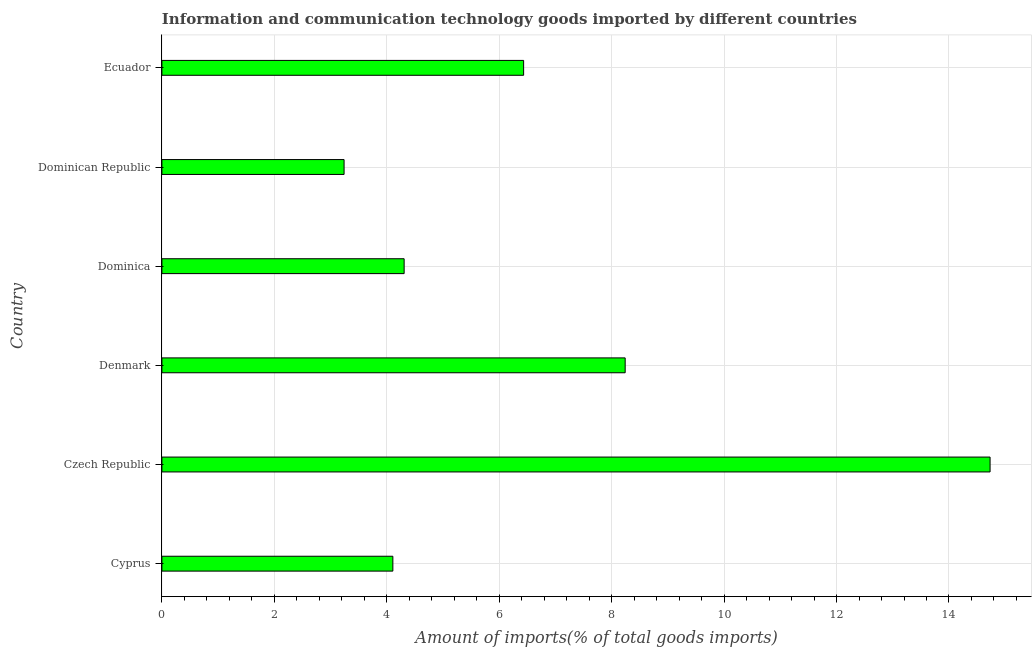Does the graph contain any zero values?
Offer a terse response. No. Does the graph contain grids?
Your answer should be compact. Yes. What is the title of the graph?
Offer a very short reply. Information and communication technology goods imported by different countries. What is the label or title of the X-axis?
Keep it short and to the point. Amount of imports(% of total goods imports). What is the label or title of the Y-axis?
Ensure brevity in your answer.  Country. What is the amount of ict goods imports in Cyprus?
Offer a terse response. 4.11. Across all countries, what is the maximum amount of ict goods imports?
Your answer should be very brief. 14.73. Across all countries, what is the minimum amount of ict goods imports?
Provide a short and direct response. 3.24. In which country was the amount of ict goods imports maximum?
Provide a short and direct response. Czech Republic. In which country was the amount of ict goods imports minimum?
Your answer should be very brief. Dominican Republic. What is the sum of the amount of ict goods imports?
Your response must be concise. 41.06. What is the difference between the amount of ict goods imports in Denmark and Dominica?
Make the answer very short. 3.93. What is the average amount of ict goods imports per country?
Ensure brevity in your answer.  6.84. What is the median amount of ict goods imports?
Your answer should be compact. 5.37. What is the ratio of the amount of ict goods imports in Denmark to that in Ecuador?
Your answer should be very brief. 1.28. Is the amount of ict goods imports in Dominica less than that in Dominican Republic?
Give a very brief answer. No. Is the difference between the amount of ict goods imports in Cyprus and Czech Republic greater than the difference between any two countries?
Offer a very short reply. No. What is the difference between the highest and the second highest amount of ict goods imports?
Offer a terse response. 6.49. Is the sum of the amount of ict goods imports in Czech Republic and Dominica greater than the maximum amount of ict goods imports across all countries?
Your response must be concise. Yes. What is the difference between the highest and the lowest amount of ict goods imports?
Your answer should be very brief. 11.49. How many bars are there?
Your response must be concise. 6. How many countries are there in the graph?
Provide a short and direct response. 6. What is the difference between two consecutive major ticks on the X-axis?
Give a very brief answer. 2. Are the values on the major ticks of X-axis written in scientific E-notation?
Keep it short and to the point. No. What is the Amount of imports(% of total goods imports) of Cyprus?
Provide a short and direct response. 4.11. What is the Amount of imports(% of total goods imports) of Czech Republic?
Your answer should be compact. 14.73. What is the Amount of imports(% of total goods imports) of Denmark?
Offer a very short reply. 8.24. What is the Amount of imports(% of total goods imports) of Dominica?
Your answer should be compact. 4.31. What is the Amount of imports(% of total goods imports) in Dominican Republic?
Make the answer very short. 3.24. What is the Amount of imports(% of total goods imports) of Ecuador?
Ensure brevity in your answer.  6.43. What is the difference between the Amount of imports(% of total goods imports) in Cyprus and Czech Republic?
Offer a very short reply. -10.62. What is the difference between the Amount of imports(% of total goods imports) in Cyprus and Denmark?
Ensure brevity in your answer.  -4.13. What is the difference between the Amount of imports(% of total goods imports) in Cyprus and Dominica?
Give a very brief answer. -0.2. What is the difference between the Amount of imports(% of total goods imports) in Cyprus and Dominican Republic?
Your answer should be very brief. 0.87. What is the difference between the Amount of imports(% of total goods imports) in Cyprus and Ecuador?
Your answer should be very brief. -2.33. What is the difference between the Amount of imports(% of total goods imports) in Czech Republic and Denmark?
Provide a short and direct response. 6.49. What is the difference between the Amount of imports(% of total goods imports) in Czech Republic and Dominica?
Your answer should be compact. 10.42. What is the difference between the Amount of imports(% of total goods imports) in Czech Republic and Dominican Republic?
Your answer should be very brief. 11.49. What is the difference between the Amount of imports(% of total goods imports) in Czech Republic and Ecuador?
Your answer should be very brief. 8.3. What is the difference between the Amount of imports(% of total goods imports) in Denmark and Dominica?
Keep it short and to the point. 3.93. What is the difference between the Amount of imports(% of total goods imports) in Denmark and Dominican Republic?
Provide a succinct answer. 5. What is the difference between the Amount of imports(% of total goods imports) in Denmark and Ecuador?
Give a very brief answer. 1.81. What is the difference between the Amount of imports(% of total goods imports) in Dominica and Dominican Republic?
Provide a succinct answer. 1.07. What is the difference between the Amount of imports(% of total goods imports) in Dominica and Ecuador?
Provide a succinct answer. -2.13. What is the difference between the Amount of imports(% of total goods imports) in Dominican Republic and Ecuador?
Provide a short and direct response. -3.19. What is the ratio of the Amount of imports(% of total goods imports) in Cyprus to that in Czech Republic?
Ensure brevity in your answer.  0.28. What is the ratio of the Amount of imports(% of total goods imports) in Cyprus to that in Denmark?
Provide a short and direct response. 0.5. What is the ratio of the Amount of imports(% of total goods imports) in Cyprus to that in Dominica?
Give a very brief answer. 0.95. What is the ratio of the Amount of imports(% of total goods imports) in Cyprus to that in Dominican Republic?
Give a very brief answer. 1.27. What is the ratio of the Amount of imports(% of total goods imports) in Cyprus to that in Ecuador?
Your response must be concise. 0.64. What is the ratio of the Amount of imports(% of total goods imports) in Czech Republic to that in Denmark?
Provide a short and direct response. 1.79. What is the ratio of the Amount of imports(% of total goods imports) in Czech Republic to that in Dominica?
Give a very brief answer. 3.42. What is the ratio of the Amount of imports(% of total goods imports) in Czech Republic to that in Dominican Republic?
Keep it short and to the point. 4.55. What is the ratio of the Amount of imports(% of total goods imports) in Czech Republic to that in Ecuador?
Ensure brevity in your answer.  2.29. What is the ratio of the Amount of imports(% of total goods imports) in Denmark to that in Dominica?
Your response must be concise. 1.91. What is the ratio of the Amount of imports(% of total goods imports) in Denmark to that in Dominican Republic?
Make the answer very short. 2.54. What is the ratio of the Amount of imports(% of total goods imports) in Denmark to that in Ecuador?
Keep it short and to the point. 1.28. What is the ratio of the Amount of imports(% of total goods imports) in Dominica to that in Dominican Republic?
Keep it short and to the point. 1.33. What is the ratio of the Amount of imports(% of total goods imports) in Dominica to that in Ecuador?
Ensure brevity in your answer.  0.67. What is the ratio of the Amount of imports(% of total goods imports) in Dominican Republic to that in Ecuador?
Keep it short and to the point. 0.5. 